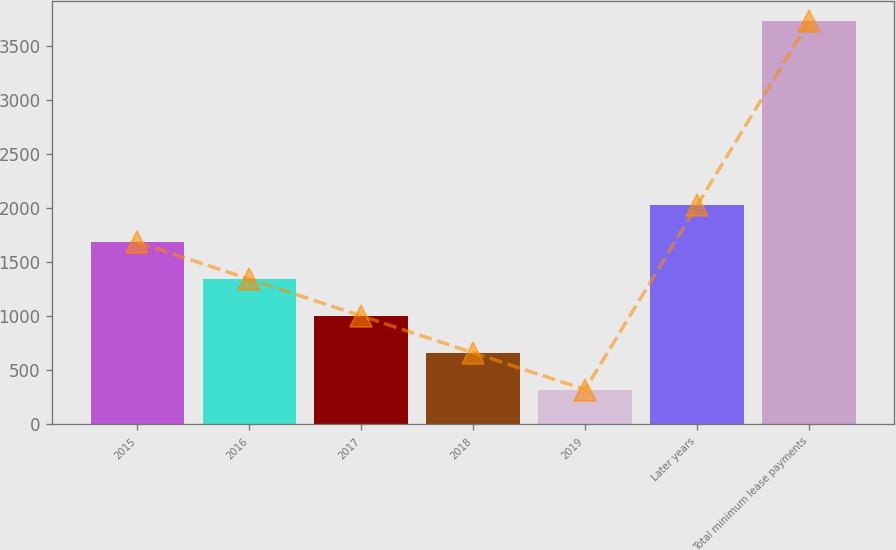Convert chart. <chart><loc_0><loc_0><loc_500><loc_500><bar_chart><fcel>2015<fcel>2016<fcel>2017<fcel>2018<fcel>2019<fcel>Later years<fcel>Total minimum lease payments<nl><fcel>1683.8<fcel>1343.6<fcel>1003.4<fcel>663.2<fcel>323<fcel>2024<fcel>3725<nl></chart> 